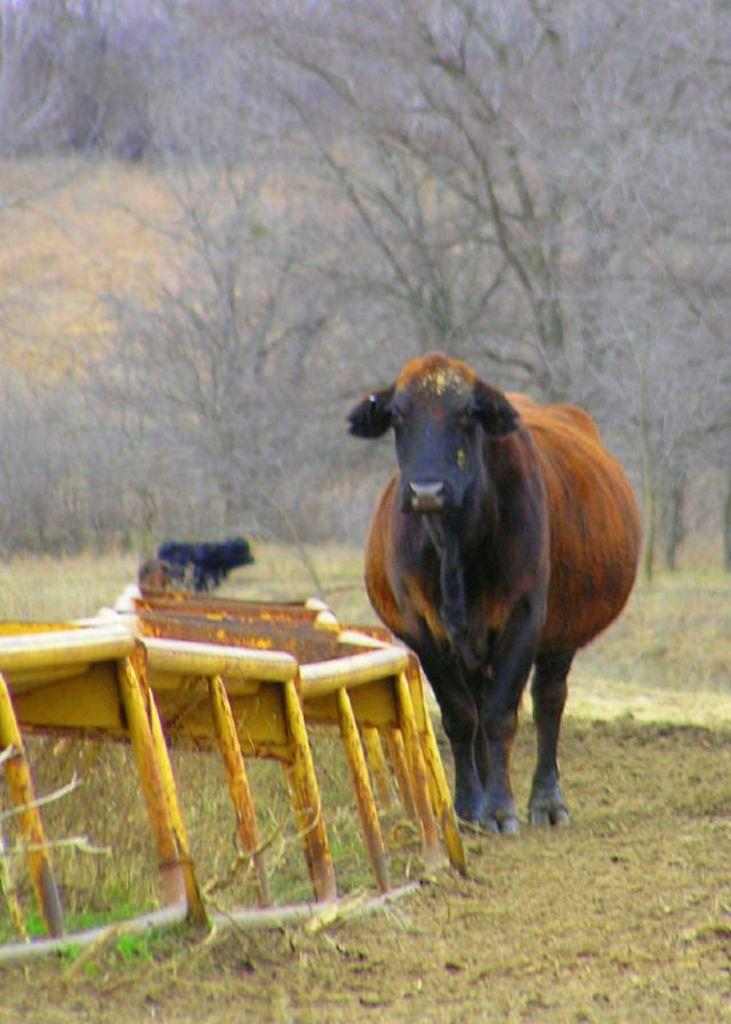What animals can be seen in the image? There are cows standing on the ground in the image. What type of terrain is the ground covered with? The ground is covered with grass. Can you describe the object made of iron rods in the image? There is an object made of iron rods in the image. What can be seen in the background of the image? There are many trees visible in the background of the image. What type of cemetery can be seen in the image? There is no cemetery present in the image; it features cows standing on grass-covered ground. What is the middle of the image occupied by? The provided facts do not mention anything specific about the middle of the image, so it cannot be determined from the information given. 